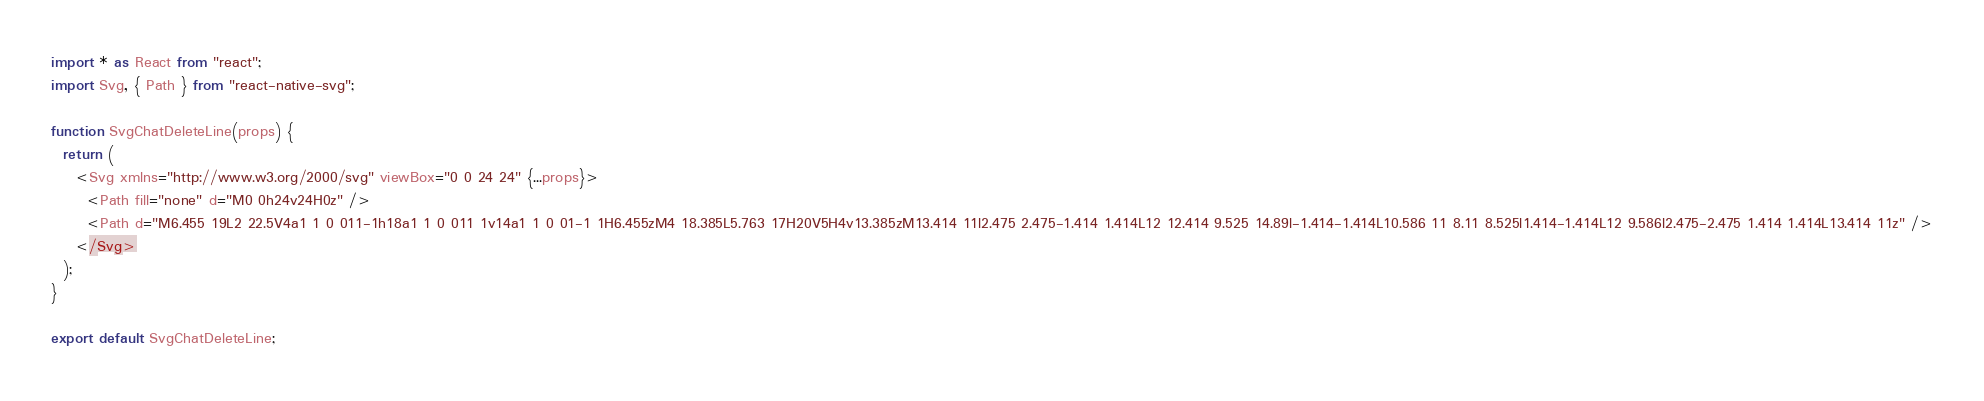<code> <loc_0><loc_0><loc_500><loc_500><_JavaScript_>import * as React from "react";
import Svg, { Path } from "react-native-svg";

function SvgChatDeleteLine(props) {
  return (
    <Svg xmlns="http://www.w3.org/2000/svg" viewBox="0 0 24 24" {...props}>
      <Path fill="none" d="M0 0h24v24H0z" />
      <Path d="M6.455 19L2 22.5V4a1 1 0 011-1h18a1 1 0 011 1v14a1 1 0 01-1 1H6.455zM4 18.385L5.763 17H20V5H4v13.385zM13.414 11l2.475 2.475-1.414 1.414L12 12.414 9.525 14.89l-1.414-1.414L10.586 11 8.11 8.525l1.414-1.414L12 9.586l2.475-2.475 1.414 1.414L13.414 11z" />
    </Svg>
  );
}

export default SvgChatDeleteLine;
</code> 